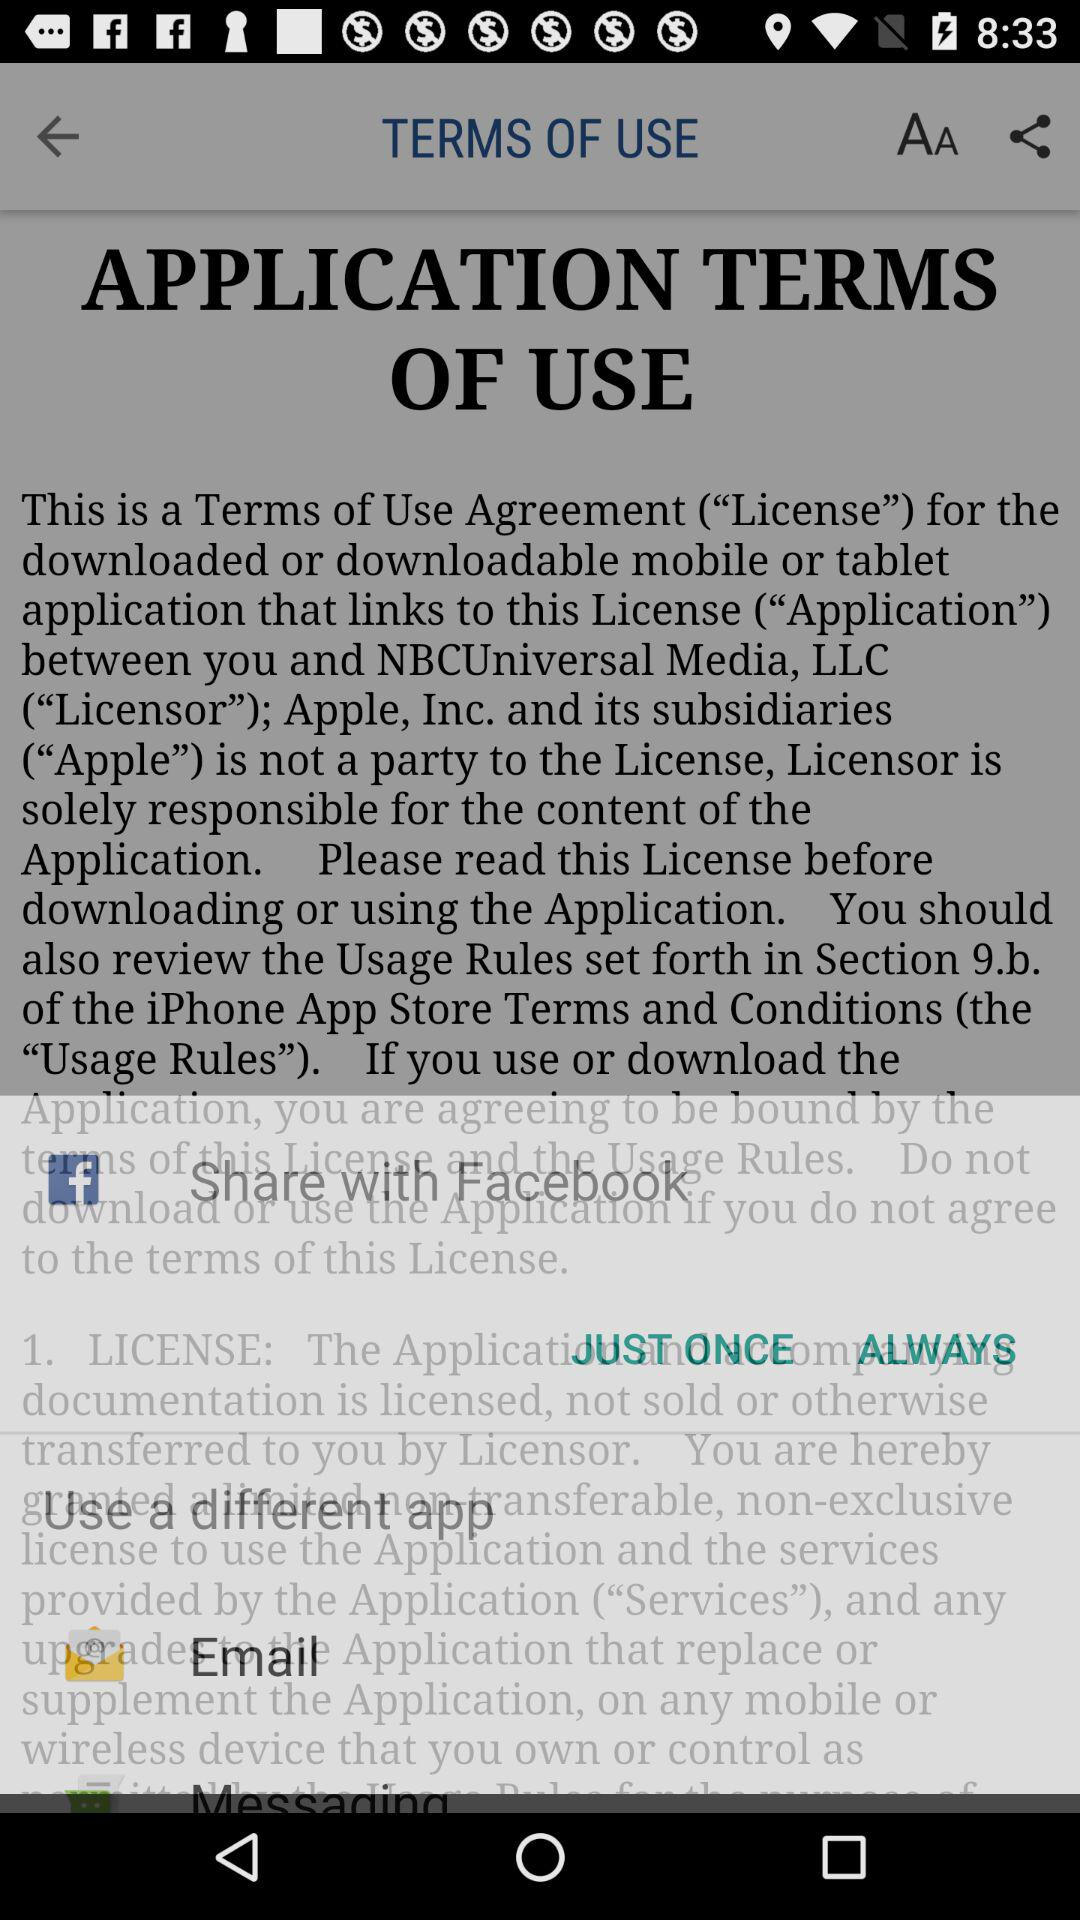Which app can we use to share? You can use "Facebook" and "Email" apps to share. 